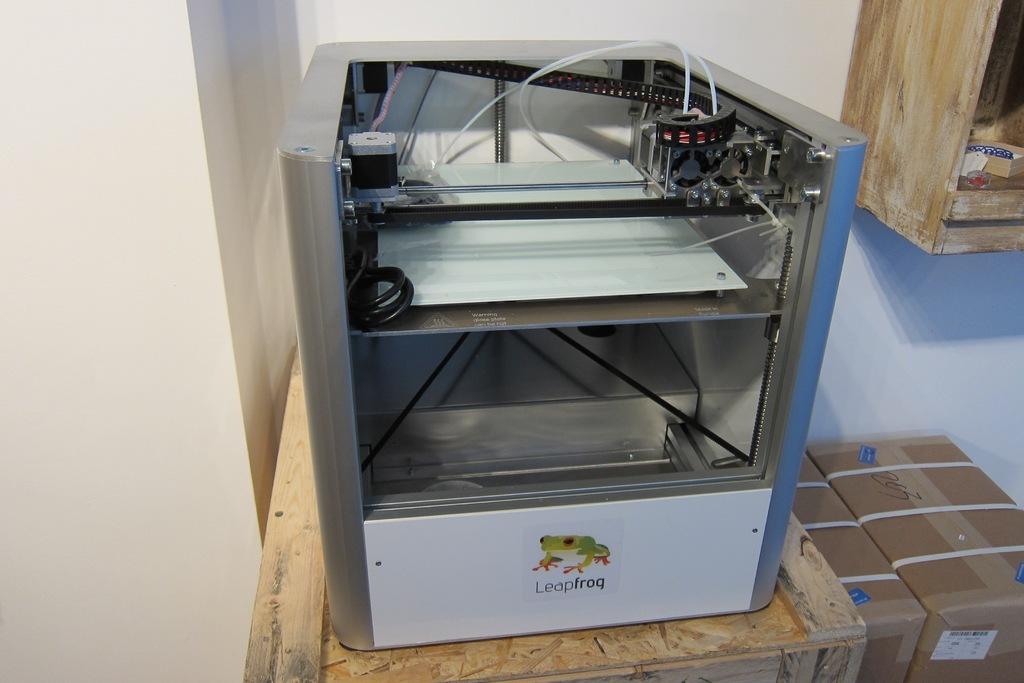What is written bleow the picture of the frog?
Give a very brief answer. Leapfrog. What is the machine?
Your response must be concise. Leapfrog. 